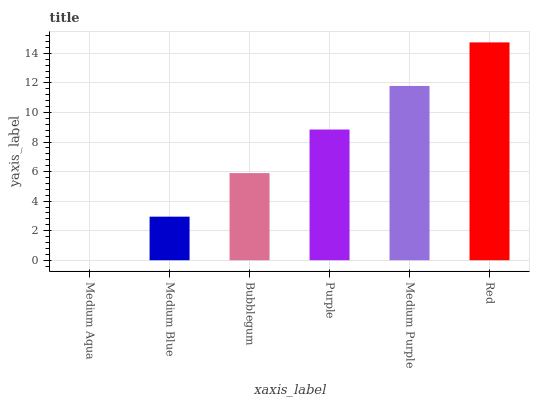Is Medium Aqua the minimum?
Answer yes or no. Yes. Is Red the maximum?
Answer yes or no. Yes. Is Medium Blue the minimum?
Answer yes or no. No. Is Medium Blue the maximum?
Answer yes or no. No. Is Medium Blue greater than Medium Aqua?
Answer yes or no. Yes. Is Medium Aqua less than Medium Blue?
Answer yes or no. Yes. Is Medium Aqua greater than Medium Blue?
Answer yes or no. No. Is Medium Blue less than Medium Aqua?
Answer yes or no. No. Is Purple the high median?
Answer yes or no. Yes. Is Bubblegum the low median?
Answer yes or no. Yes. Is Medium Aqua the high median?
Answer yes or no. No. Is Medium Blue the low median?
Answer yes or no. No. 